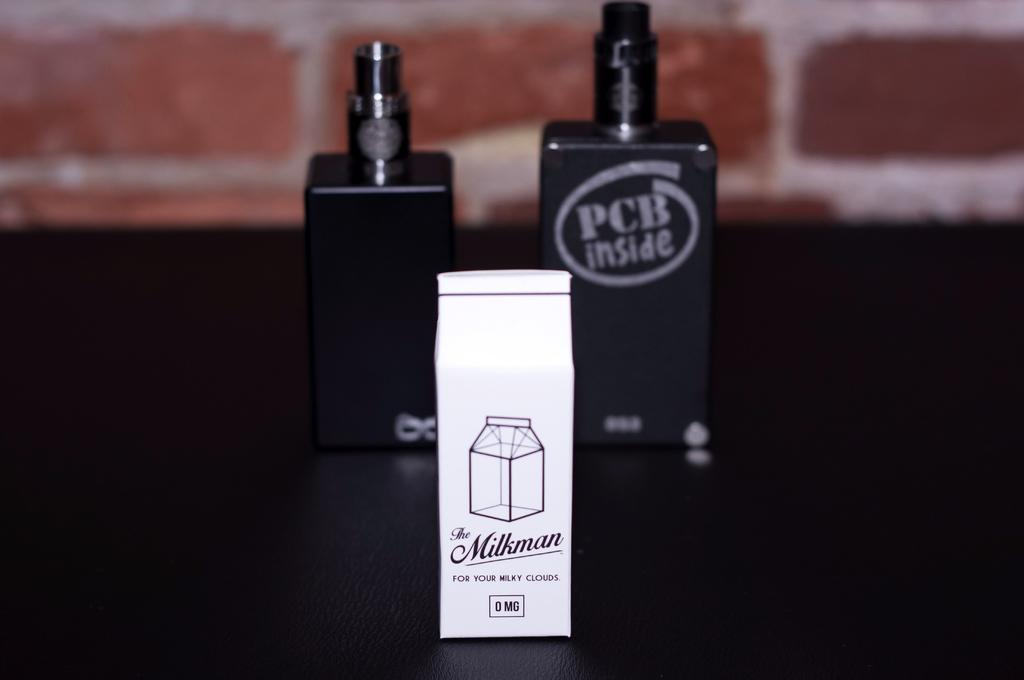<image>
Present a compact description of the photo's key features. A white box sitting on a table which is called The Milkman. 